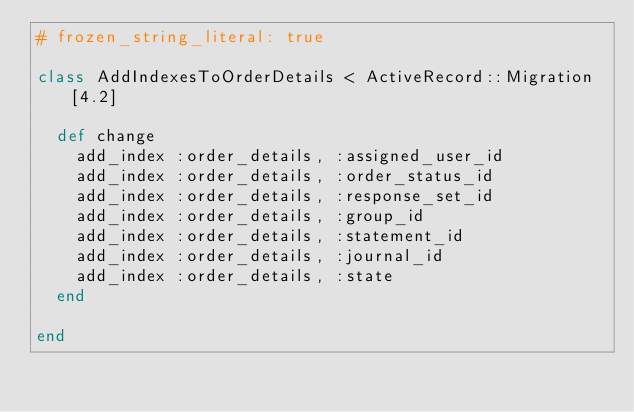<code> <loc_0><loc_0><loc_500><loc_500><_Ruby_># frozen_string_literal: true

class AddIndexesToOrderDetails < ActiveRecord::Migration[4.2]

  def change
    add_index :order_details, :assigned_user_id
    add_index :order_details, :order_status_id
    add_index :order_details, :response_set_id
    add_index :order_details, :group_id
    add_index :order_details, :statement_id
    add_index :order_details, :journal_id
    add_index :order_details, :state
  end

end
</code> 